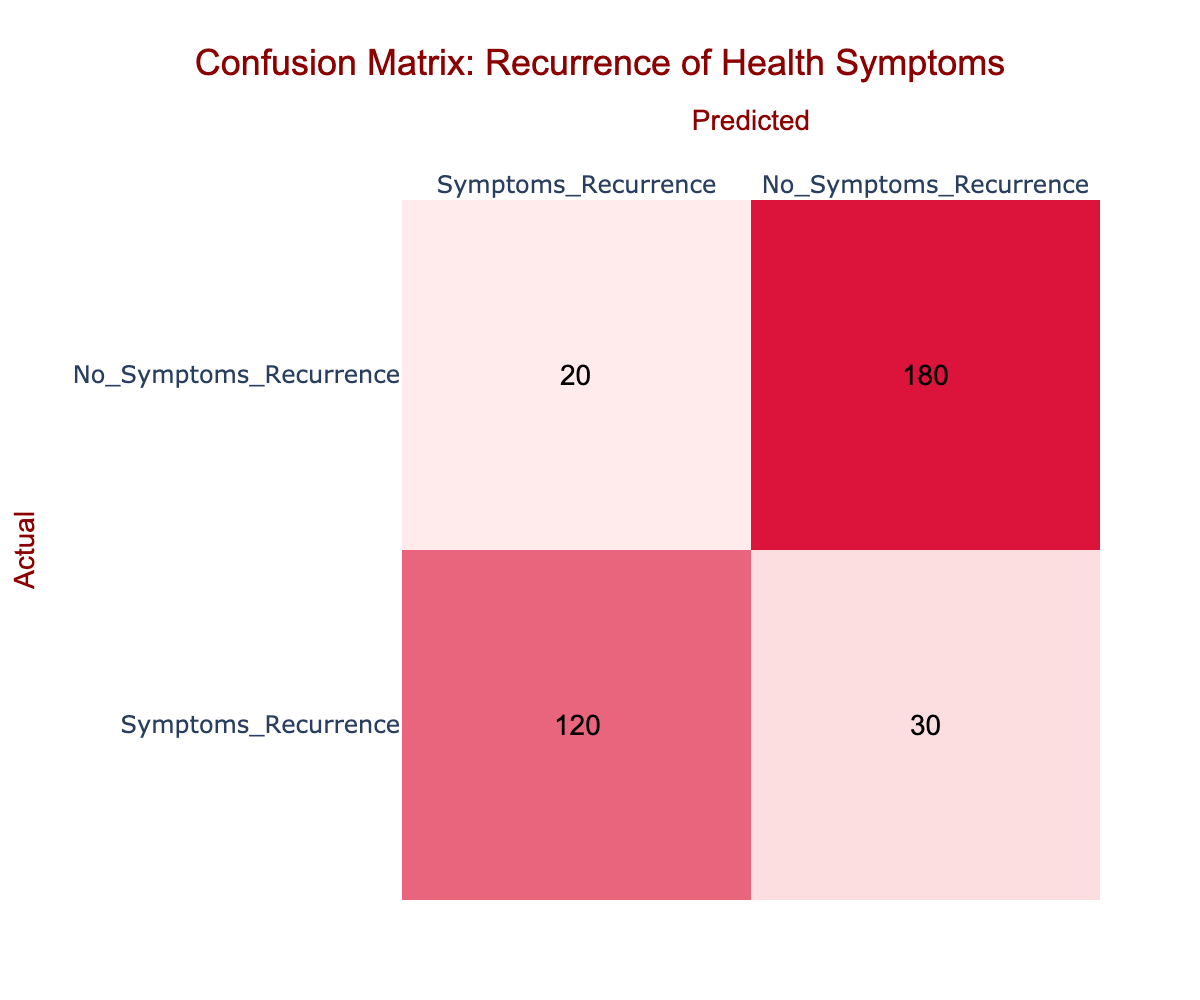What is the total number of participants with symptoms recurrence? The table shows that there are 120 participants who had symptoms recurrence, and 30 participants who had no symptoms recurrence but were predicted to. Therefore, the total number of participants with symptoms recurrence is 120 + 30 = 150.
Answer: 150 What is the total number of participants without symptoms recurrence? The table indicates that there are 180 participants who had no symptoms recurrence and 20 participants who were predicted to have symptoms recurrence. Thus, the total number of participants without symptoms recurrence is 180 + 20 = 200.
Answer: 200 What is the percentage of true positive cases for symptoms recurrence? There are 120 true positive cases (symptoms recurrence) out of a total of 150 actual symptoms recurrence cases (120 true positives + 30 false negatives). The percentage is calculated as (120/150) * 100 = 80%.
Answer: 80% Is there a higher number of false positives or false negatives? The false positive count is 20, while the false negative count is 30. Since 30 is greater than 20, there are more false negatives than false positives.
Answer: Yes What is the total number of false negatives and false positives combined? The false negatives are 30 and the false positives are 20. To find the total, add these together: 30 + 20 = 50.
Answer: 50 What is the accuracy of the prediction model based on this data? The accuracy is given by the formula (True Positives + True Negatives) / Total Cases. Here, True Positives (TP) = 120, True Negatives (TN) = 180, and Total Cases = 120 + 30 + 20 + 180 = 350. Therefore, accuracy = (120 + 180) / 350 = 300 / 350 = 0.857 or 85.7%.
Answer: 85.7% What is the ratio of participants who had symptoms recurrence to those who did not? The number of participants with symptoms recurrence is 150 (120 true + 30 false) and those without symptoms recurrence is 200 (180 true + 20 false). The ratio is 150:200, which simplifies to 3:4.
Answer: 3:4 Is the number of participants with symptoms recurrence greater than those without? The total number of participants with symptoms recurrence is 150, while those without is 200. Since 150 is less than 200, the number of participants with symptoms is not greater.
Answer: No What is the total number of predictions made? The total predictions include all cells in the table: 120 (TP) + 30 (FN) + 20 (FP) + 180 (TN) = 350 predictions in total.
Answer: 350 